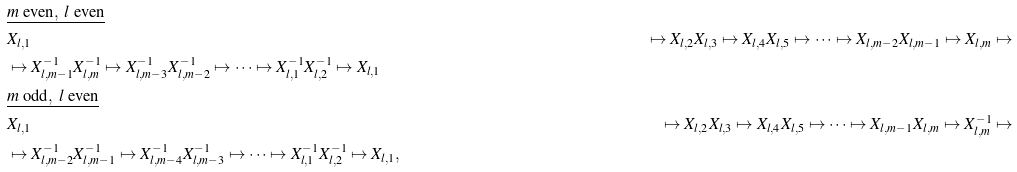<formula> <loc_0><loc_0><loc_500><loc_500>& \underline { m \ \text {even} , \ l \ \text {even} } \\ & X _ { l , 1 } & \mapsto X _ { l , 2 } X _ { l , 3 } \mapsto X _ { l , 4 } X _ { l , 5 } \mapsto \cdots \mapsto X _ { l , m - 2 } X _ { l , m - 1 } \mapsto X _ { l , m } \mapsto \\ & \mapsto X _ { l , m - 1 } ^ { - 1 } X _ { l , m } ^ { - 1 } \mapsto X ^ { - 1 } _ { l , m - 3 } X ^ { - 1 } _ { l , m - 2 } \mapsto \cdots \mapsto X ^ { - 1 } _ { l , 1 } X _ { l , 2 } ^ { - 1 } \mapsto X _ { l , 1 } \\ & \underline { m \ \text {odd} , \ l \ \text {even} } \\ & X _ { l , 1 } & \mapsto X _ { l , 2 } X _ { l , 3 } \mapsto X _ { l , 4 } X _ { l , 5 } \mapsto \cdots \mapsto X _ { l , m - 1 } X _ { l , m } \mapsto X _ { l , m } ^ { - 1 } \mapsto \\ & \mapsto X _ { l , m - 2 } ^ { - 1 } X _ { l , m - 1 } ^ { - 1 } \mapsto X ^ { - 1 } _ { l , m - 4 } X ^ { - 1 } _ { l , m - 3 } \mapsto \cdots \mapsto X ^ { - 1 } _ { l , 1 } X _ { l , 2 } ^ { - 1 } \mapsto X _ { l , 1 } ,</formula> 